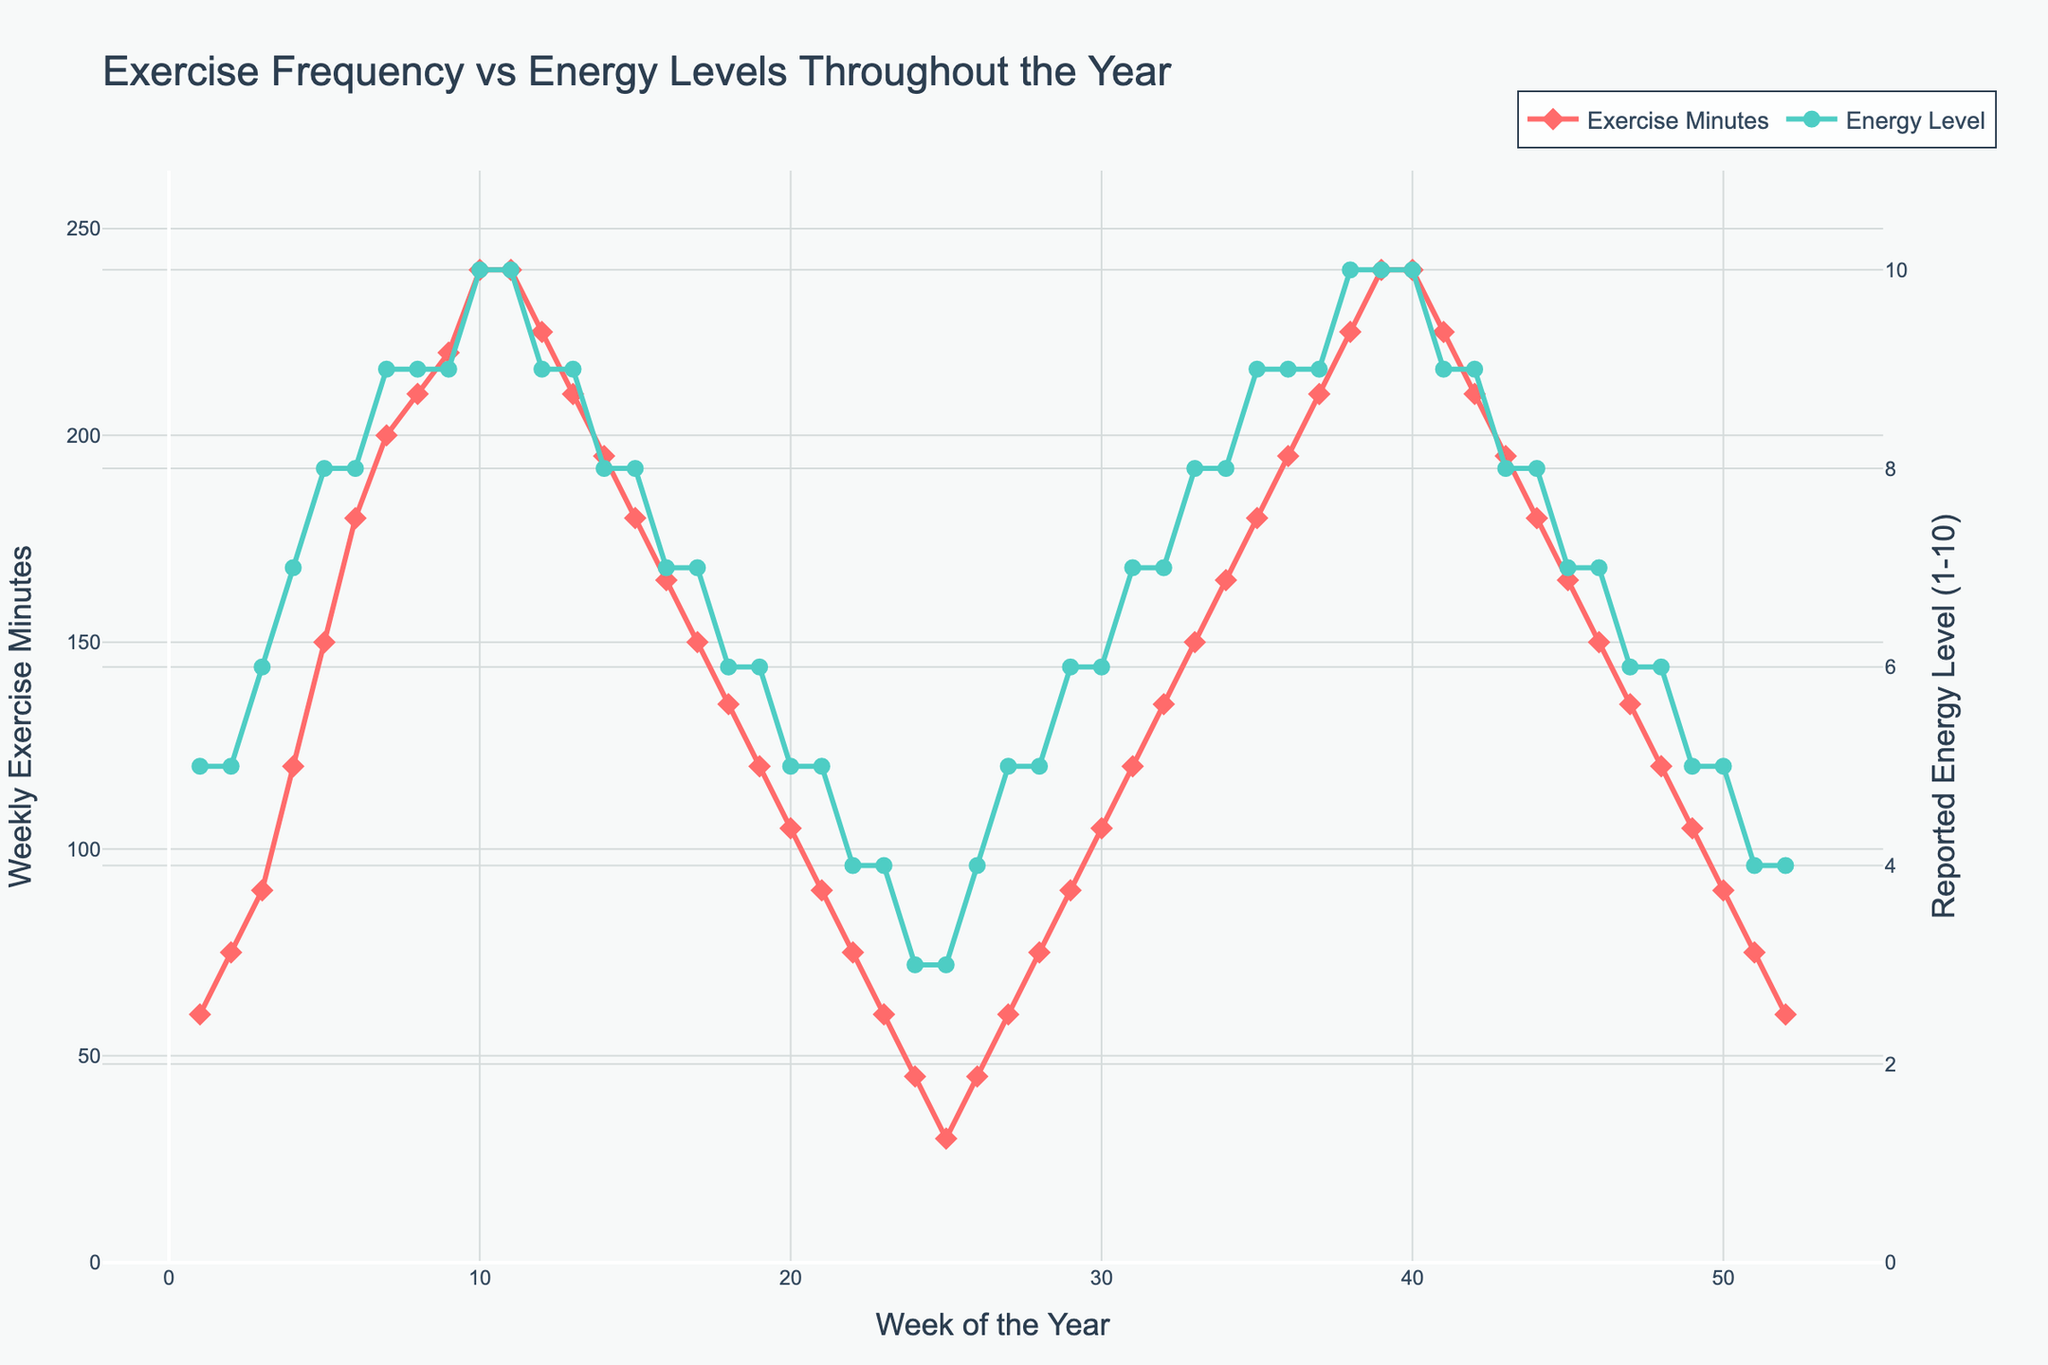What is the correlation between Weekly Exercise Minutes and Reported Energy Level? A positive correlation is observed, as increased Weekly Exercise Minutes generally align with higher Reported Energy Level, seen by the ascent and descent trends together.
Answer: Positive Are there any instances where the Energy Level remains constant despite changes in Weekly Exercise Minutes? Examine the green line's flat segments while checking for variations in the red line. Notably, around weeks 5-6, Energy Levels (8) remain constant despite an increase in Weekly Exercise Minutes from 150–180.
Answer: Weeks 5-6 How do Energy Levels change in the last 10 weeks of the year as Weekly Exercise Minutes decline? From weeks 42 to 52, Weekly Exercise Minutes decrease from 210 to 60, while Energy Levels drop from 9 to 4, indicating a decreasing trend.
Answer: Decrease to 4 What is the average Reported Energy Level during weeks when Weekly Exercise Minutes are 150? In weeks 5, 17, 33, and 46 when Weekly Exercise Minutes are 150, Energy Levels are 8, 7, 8, and 7 respectively. (8+7+8+7)/4 = 7.5
Answer: 7.5 Between which weeks is the most significant drop in Weekly Exercise Minutes observed, and how does it impact the Energy Level? The steepest decline occurs between weeks 10 and 12 (240 to 225) and correlating Energy Level drops from 10 to 9.
Answer: Weeks 10-12 What period shows the longest duration of stable energy level, and what happens to the related exercise amount? From weeks 6 to 7, and then 37 to 38, energy level remains stable at 9 while Weekly Exercise Minutes are 210 and 220, respectively demonstrating correlation alignment.
Answer: Weeks 37-38 When does the smallest increase in Energy Level occur relative to the increase in Weekly Exercise Minutes towards the end of the year? Weeks 46-47, Weekly Exercise Minutes increase from 150 to 135, but Energy Level remains M constant at 7; demonstrating less correlation during this period.
Answer: Weeks 46-47 